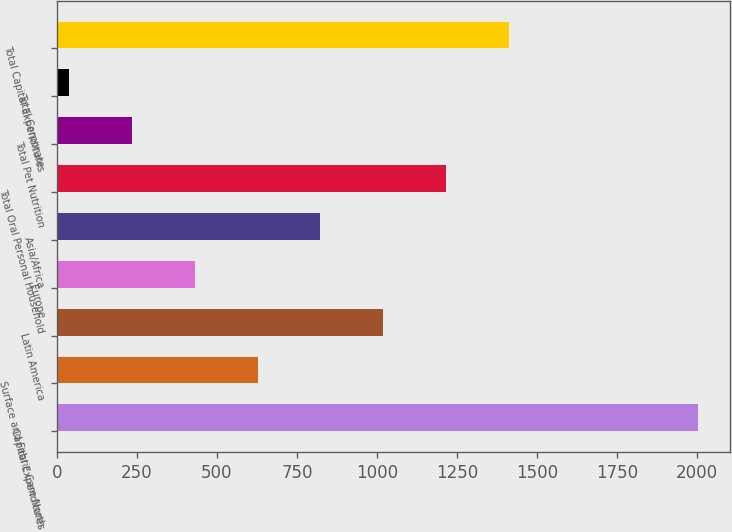<chart> <loc_0><loc_0><loc_500><loc_500><bar_chart><fcel>Capital Expenditures<fcel>Surface and Fabric Care North<fcel>Latin America<fcel>Europe<fcel>Asia/Africa<fcel>Total Oral Personal Household<fcel>Total Pet Nutrition<fcel>Total Corporate<fcel>Total Capital Expenditures<nl><fcel>2003<fcel>626.87<fcel>1020.05<fcel>430.28<fcel>823.46<fcel>1216.64<fcel>233.69<fcel>37.1<fcel>1413.23<nl></chart> 